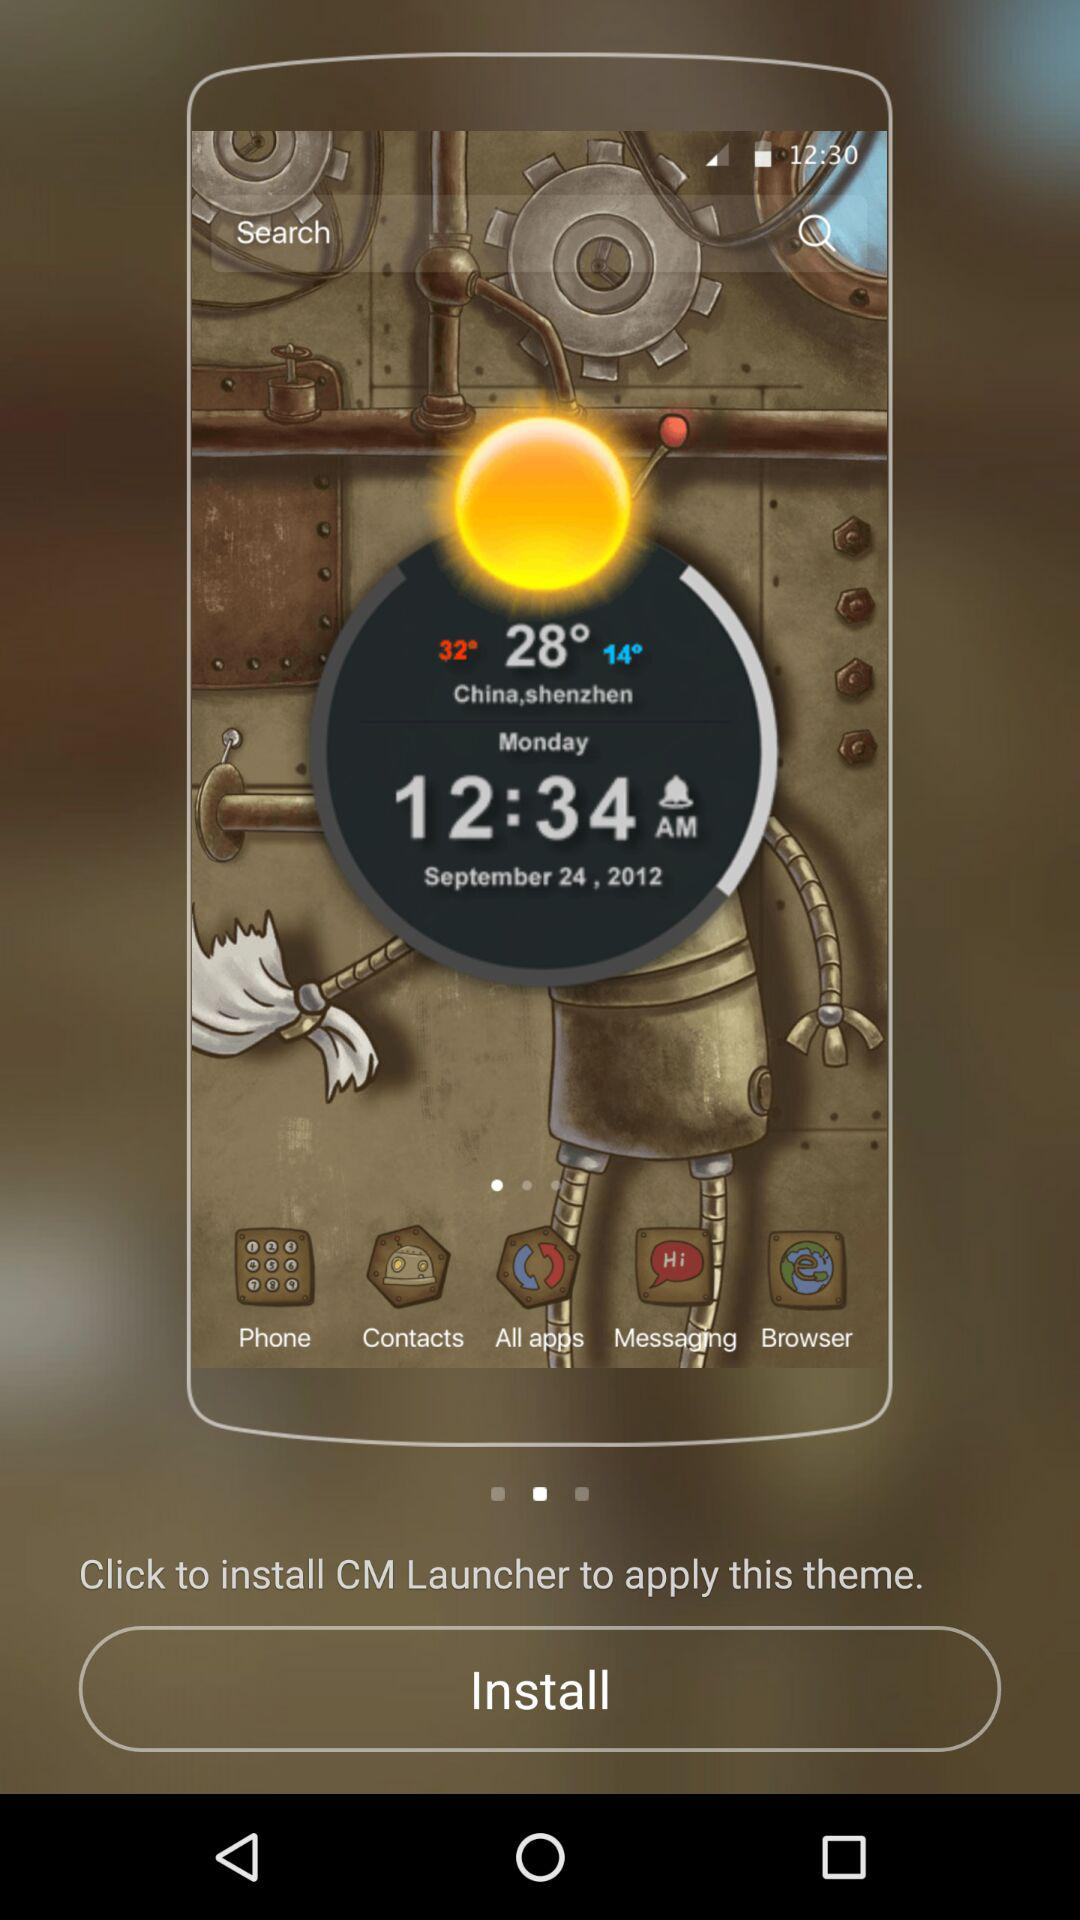What date is reflected on the screen? The date that is reflected on the screen is September 24, 2012. 